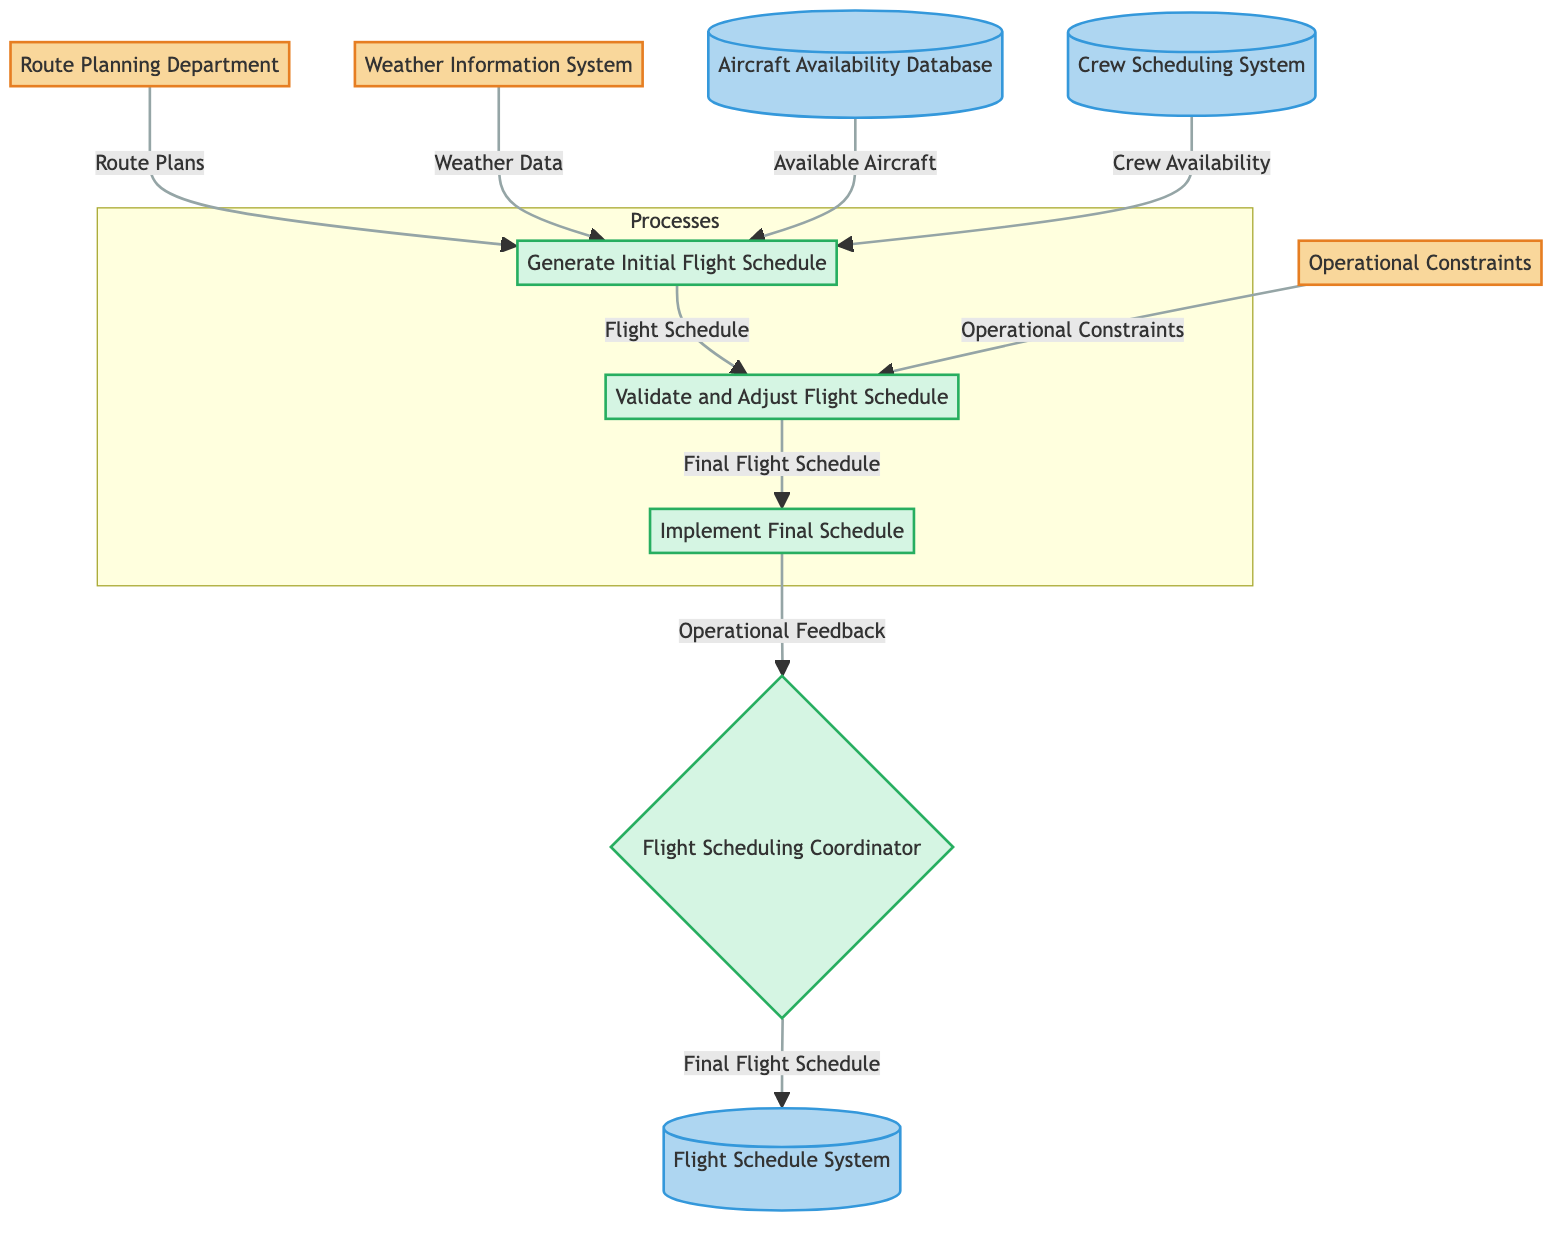What are the inputs to the Generate Initial Flight Schedule process? The inputs to the Generate Initial Flight Schedule process, as shown in the diagram, are Route Plans, Weather Data, Available Aircraft, and Crew Availability.
Answer: Route Plans, Weather Data, Available Aircraft, Crew Availability How many data stores are present in the diagram? The diagram displays three data stores, namely the Aircraft Availability Database, Crew Scheduling System, and Flight Schedule System.
Answer: Three What is the output of the Validate and Adjust Flight Schedule process? The output from the Validate and Adjust Flight Schedule process is the Final Flight Schedule, which connects the process with the Implement Final Schedule process.
Answer: Final Flight Schedule Which entity provides the Weather Data? The Weather Information System entity provides the Weather Data to the Generate Initial Flight Schedule process.
Answer: Weather Information System In what order do the processes occur in the diagram? The processes occur in the following order: Generate Initial Flight Schedule, Validate and Adjust Flight Schedule, and Implement Final Schedule. This sequential flow is shown in the diagram's structure.
Answer: Generate Initial Flight Schedule, Validate and Adjust Flight Schedule, Implement Final Schedule What kind of feedback is given after implementing the Final Flight Schedule? After the implementation of the Final Flight Schedule, the output is Operational Feedback, which is sent back to the Flight Scheduling Coordinator.
Answer: Operational Feedback Which external entity represents constraints on operations? The Operational Constraints external entity represents the constraints that are input into the Validate and Adjust Flight Schedule process.
Answer: Operational Constraints How does the Flight Schedule System relate to the Final Flight Schedule? The Final Flight Schedule output from the Implement Final Schedule process is sent to the Flight Schedule System, indicating that it updates or stores the final schedule for operations.
Answer: Updates or stores final schedule 